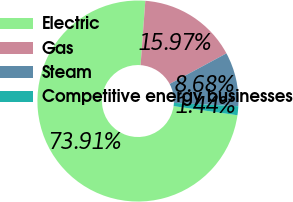Convert chart. <chart><loc_0><loc_0><loc_500><loc_500><pie_chart><fcel>Electric<fcel>Gas<fcel>Steam<fcel>Competitive energy businesses<nl><fcel>73.91%<fcel>15.97%<fcel>8.68%<fcel>1.44%<nl></chart> 